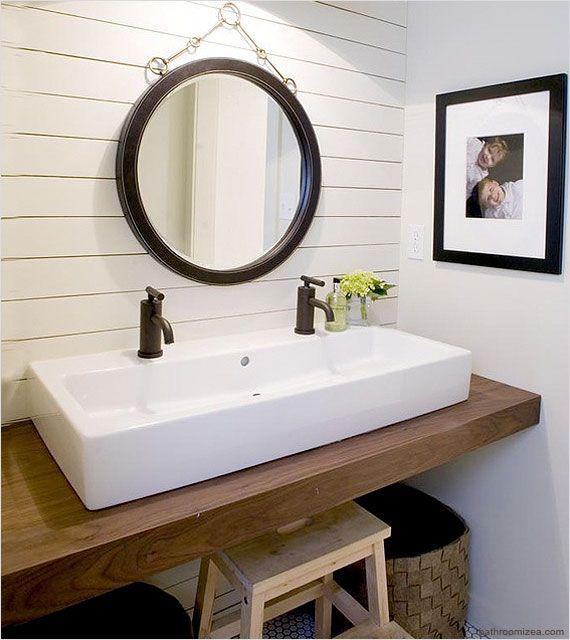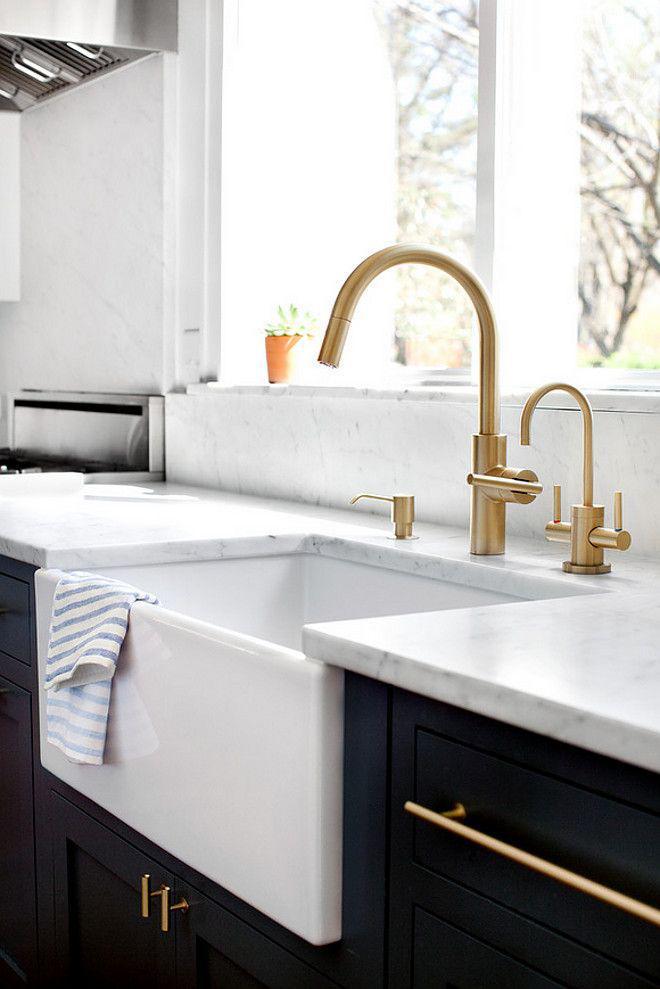The first image is the image on the left, the second image is the image on the right. For the images shown, is this caption "The counter in the image on the right is white on a black cabinet." true? Answer yes or no. Yes. The first image is the image on the left, the second image is the image on the right. Examine the images to the left and right. Is the description "An image shows a white rectangular sink with two separate faucets." accurate? Answer yes or no. Yes. 